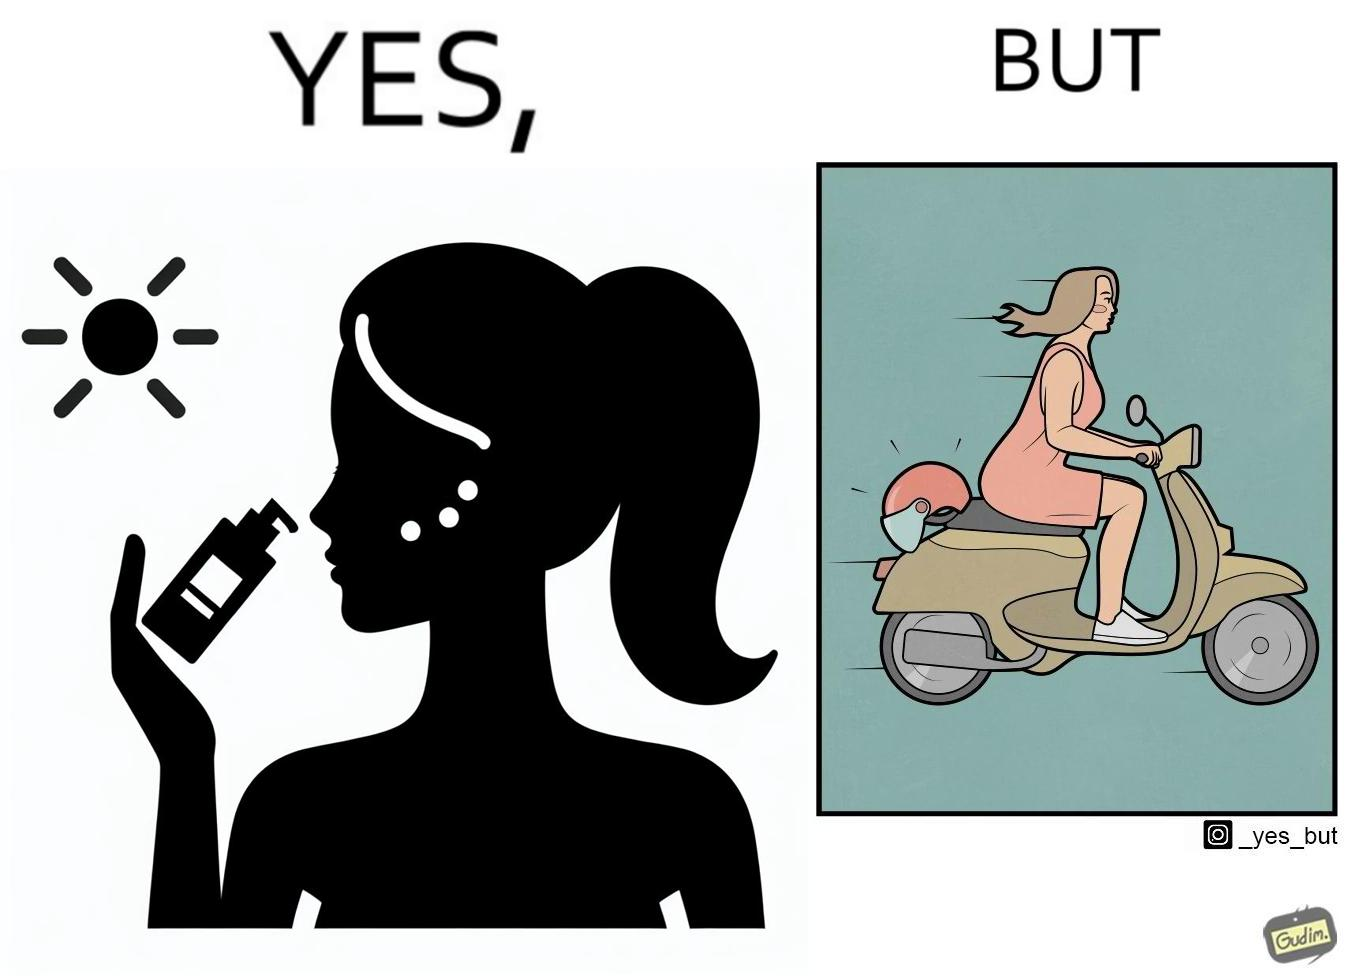Is this image satirical or non-satirical? Yes, this image is satirical. 